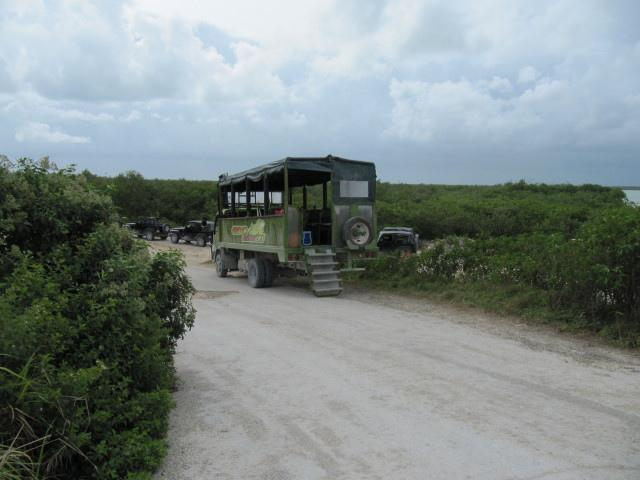What does the truck have a spare of on the back? tire 